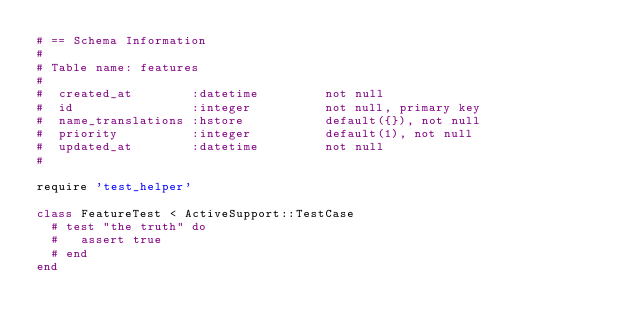Convert code to text. <code><loc_0><loc_0><loc_500><loc_500><_Ruby_># == Schema Information
#
# Table name: features
#
#  created_at        :datetime         not null
#  id                :integer          not null, primary key
#  name_translations :hstore           default({}), not null
#  priority          :integer          default(1), not null
#  updated_at        :datetime         not null
#

require 'test_helper'

class FeatureTest < ActiveSupport::TestCase
  # test "the truth" do
  #   assert true
  # end
end
</code> 